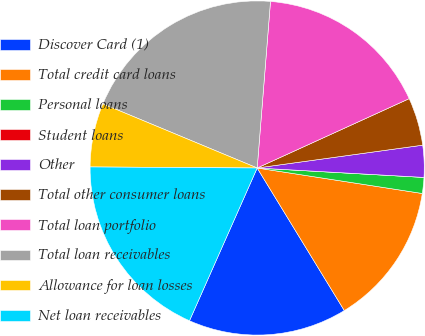Convert chart to OTSL. <chart><loc_0><loc_0><loc_500><loc_500><pie_chart><fcel>Discover Card (1)<fcel>Total credit card loans<fcel>Personal loans<fcel>Student loans<fcel>Other<fcel>Total other consumer loans<fcel>Total loan portfolio<fcel>Total loan receivables<fcel>Allowance for loan losses<fcel>Net loan receivables<nl><fcel>15.37%<fcel>13.83%<fcel>1.54%<fcel>0.0%<fcel>3.08%<fcel>4.63%<fcel>16.92%<fcel>20.0%<fcel>6.17%<fcel>18.46%<nl></chart> 